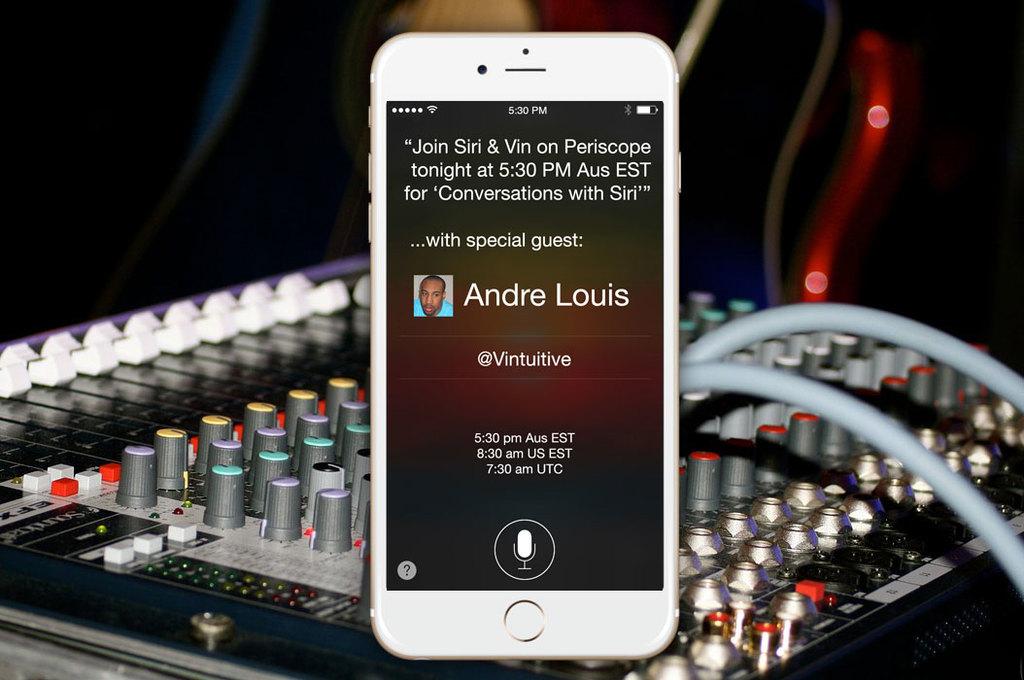Who is the special guest?
Give a very brief answer. Andre louis. 